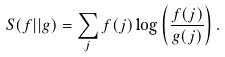Convert formula to latex. <formula><loc_0><loc_0><loc_500><loc_500>S ( f | | g ) = \sum _ { j } f ( j ) \log \left ( \frac { f ( j ) } { g ( j ) } \right ) .</formula> 